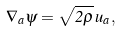<formula> <loc_0><loc_0><loc_500><loc_500>\nabla _ { a } \psi = \sqrt { 2 \rho } \, u _ { a } ,</formula> 